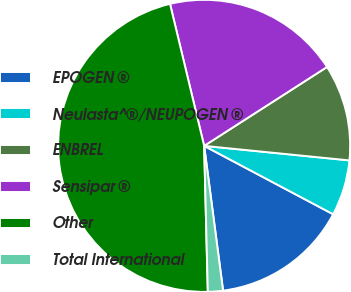<chart> <loc_0><loc_0><loc_500><loc_500><pie_chart><fcel>EPOGEN ®<fcel>Neulasta^®/NEUPOGEN ®<fcel>ENBREL<fcel>Sensipar ®<fcel>Other<fcel>Total International<nl><fcel>15.17%<fcel>6.17%<fcel>10.67%<fcel>19.67%<fcel>46.64%<fcel>1.67%<nl></chart> 